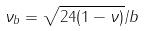Convert formula to latex. <formula><loc_0><loc_0><loc_500><loc_500>\nu _ { b } = \sqrt { 2 4 ( 1 - \nu ) } / b</formula> 